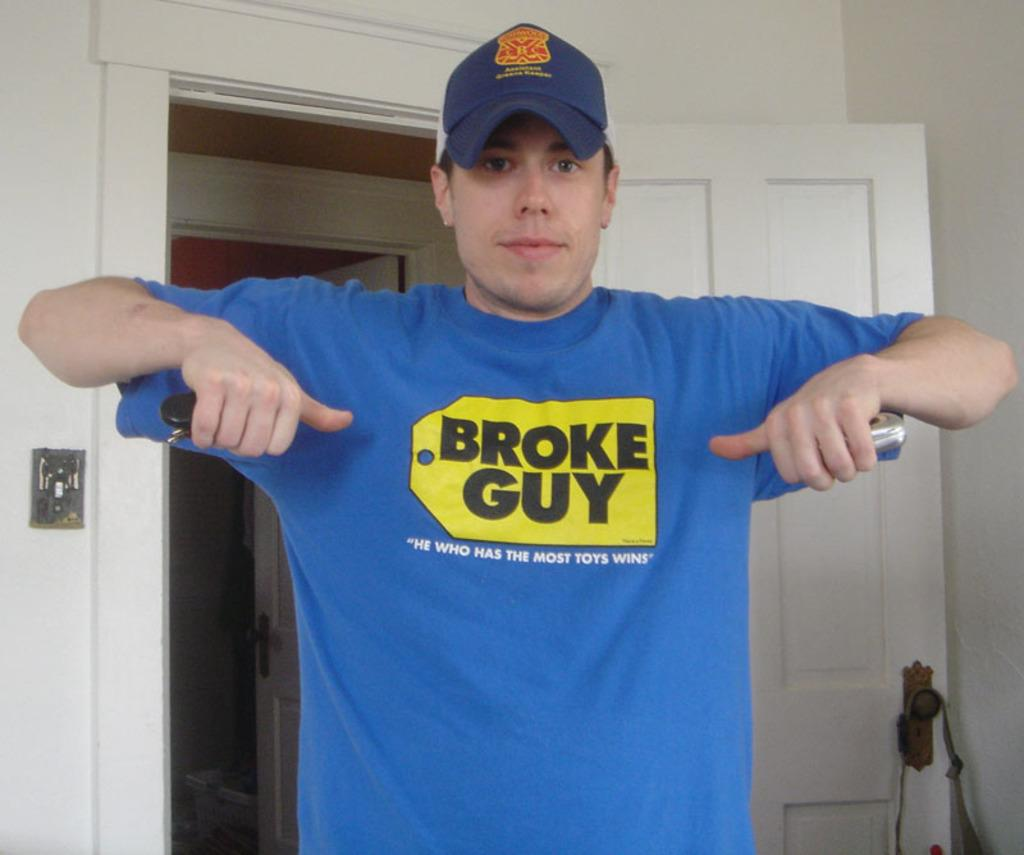<image>
Provide a brief description of the given image. A man with a baseball cap points with his thumbs at his t-shirts logo which says Broke Guy 